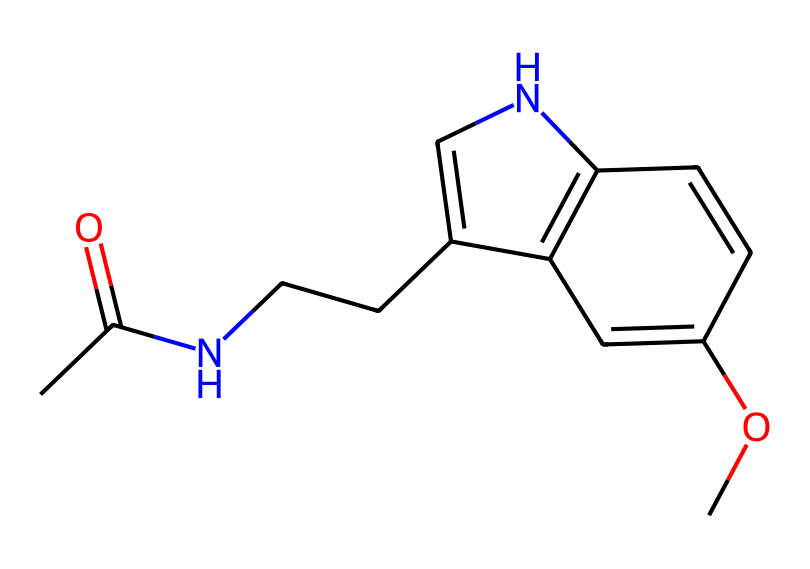How many carbon atoms are present in this chemical? By examining the SMILES notation, we count the number of "C" (carbon) symbols. There are 11 distinct carbon symbols present in the SMILES representation of this chemical structure.
Answer: 11 What is the functional group present in this molecule? In the provided SMILES, the presence of "CC(=O)" indicates a carbonyl group (C=O) which suggests that this belongs to the class of amides.
Answer: amide What is the total number of nitrogen atoms in this structure? Looking at the SMILES, we identify the number of occurrences of the letter "N". In this structure, there are 2 nitrogen atoms present.
Answer: 2 What is the primary purpose of melatonin as indicated in the chemical structure? The structure hints at the biological role of melatonin, which is associated with sleep regulation due to its hormonal function.
Answer: sleep-regulating hormone How many rings are present in the chemical structure? The presence of "1" and "2" indicates ring closures in the structure. The molecule contains two ring systems as indicated by the numbering in the SMILES.
Answer: 2 Is the compound primarily hydrophilic or hydrophobic? Due to the presence of both the carbonyl and ether functional groups (–O–), the compound exhibits characteristics that lean towards hydrophilicity, which facilitates interactions with water.
Answer: hydrophilic 